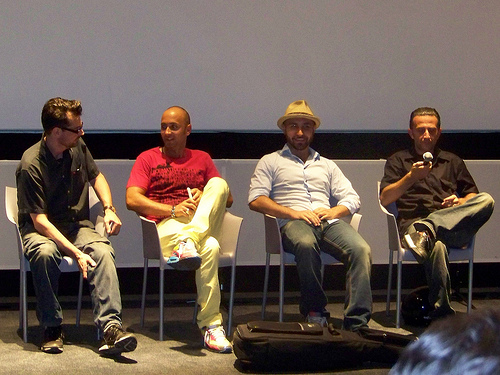<image>
Is there a man to the left of the man? Yes. From this viewpoint, the man is positioned to the left side relative to the man. Is the man to the left of the chair? No. The man is not to the left of the chair. From this viewpoint, they have a different horizontal relationship. Is the man next to the chair? No. The man is not positioned next to the chair. They are located in different areas of the scene. Is the cap above the man? No. The cap is not positioned above the man. The vertical arrangement shows a different relationship. 